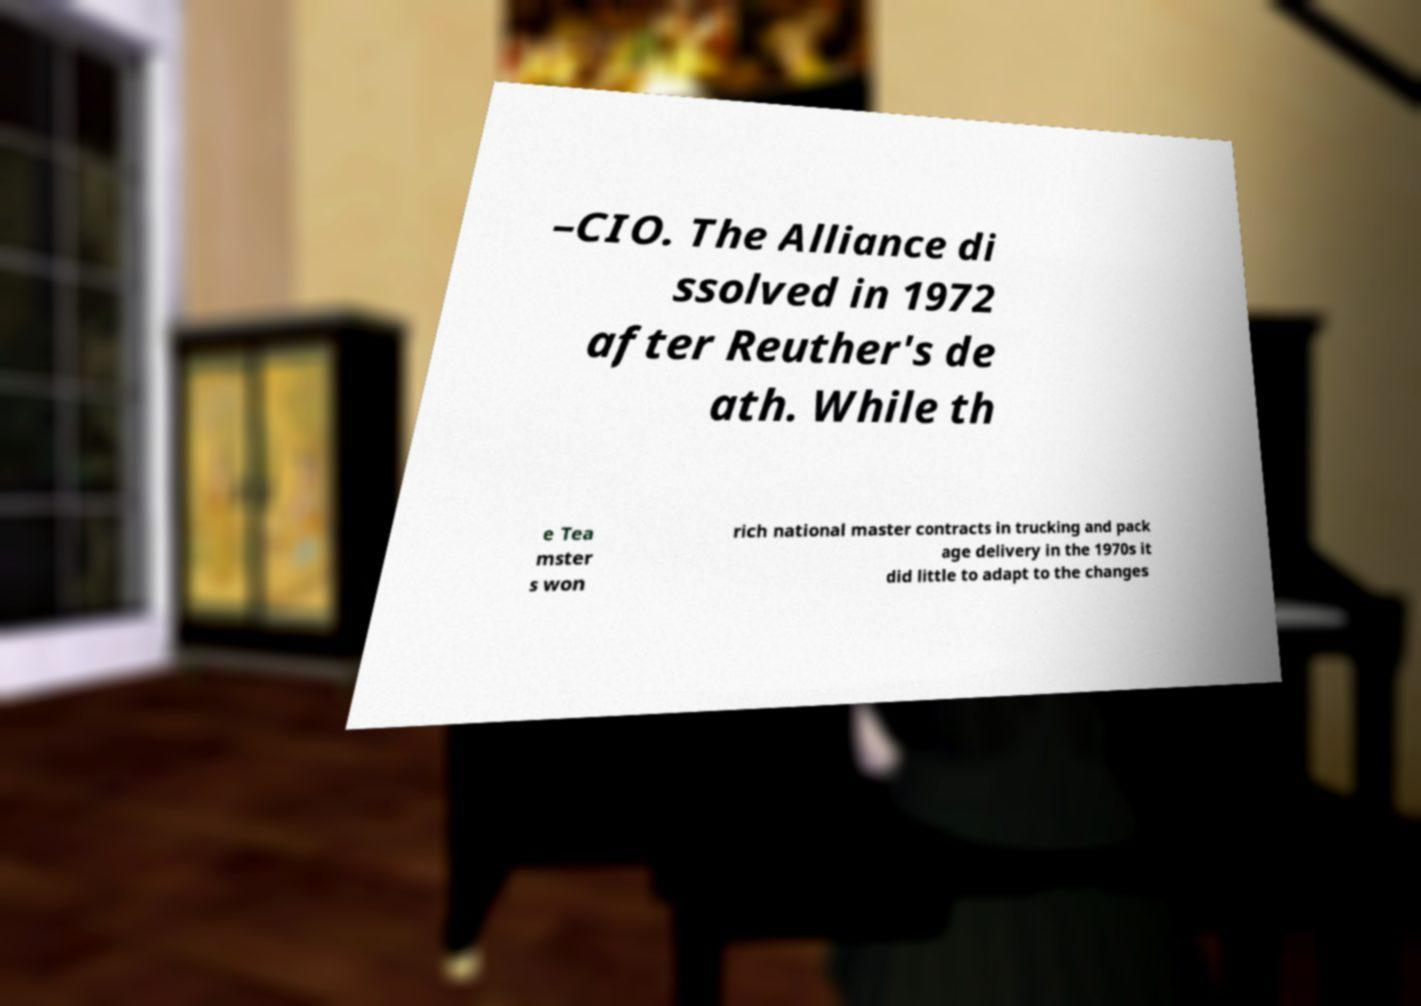Please read and relay the text visible in this image. What does it say? –CIO. The Alliance di ssolved in 1972 after Reuther's de ath. While th e Tea mster s won rich national master contracts in trucking and pack age delivery in the 1970s it did little to adapt to the changes 